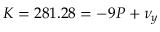<formula> <loc_0><loc_0><loc_500><loc_500>K = 2 8 1 . 2 8 = - 9 P + \nu _ { y }</formula> 